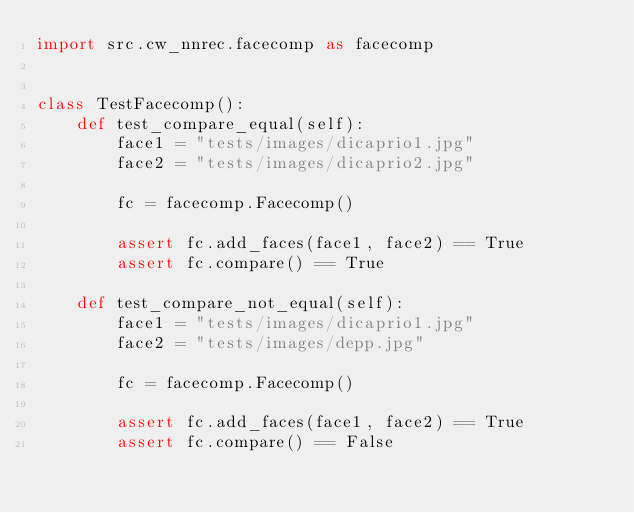Convert code to text. <code><loc_0><loc_0><loc_500><loc_500><_Python_>import src.cw_nnrec.facecomp as facecomp


class TestFacecomp():
    def test_compare_equal(self):
        face1 = "tests/images/dicaprio1.jpg"
        face2 = "tests/images/dicaprio2.jpg"

        fc = facecomp.Facecomp()

        assert fc.add_faces(face1, face2) == True
        assert fc.compare() == True

    def test_compare_not_equal(self):
        face1 = "tests/images/dicaprio1.jpg"
        face2 = "tests/images/depp.jpg"

        fc = facecomp.Facecomp()

        assert fc.add_faces(face1, face2) == True
        assert fc.compare() == False
</code> 